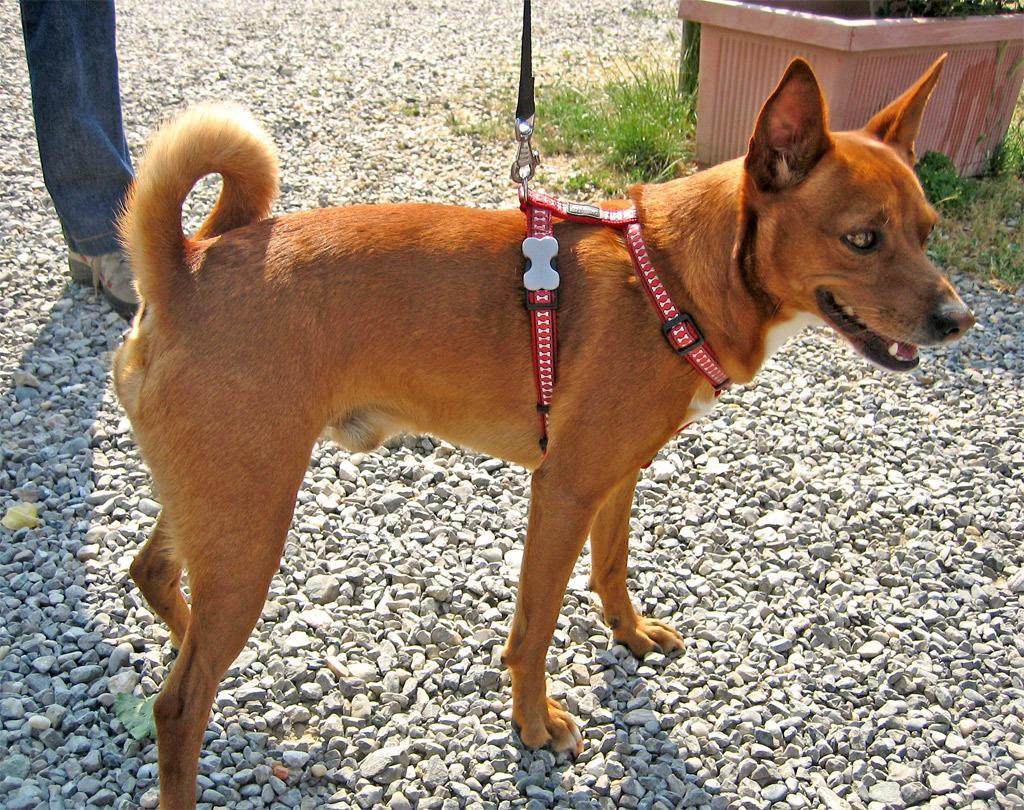Please provide a concise description of this image. In this image i can see a dog and a red color thread attached to the dog and right side I can see a flower pot and on left side I can see a person leg. 